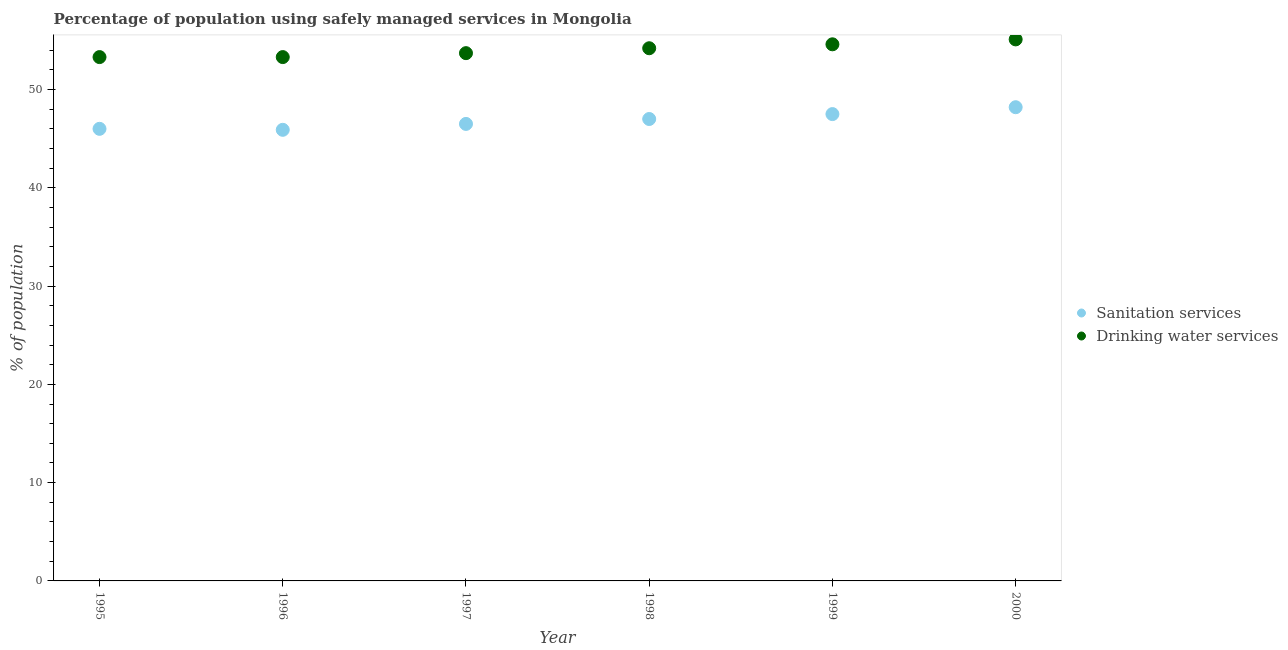Is the number of dotlines equal to the number of legend labels?
Offer a terse response. Yes. What is the percentage of population who used drinking water services in 2000?
Provide a succinct answer. 55.1. Across all years, what is the maximum percentage of population who used drinking water services?
Give a very brief answer. 55.1. Across all years, what is the minimum percentage of population who used sanitation services?
Keep it short and to the point. 45.9. In which year was the percentage of population who used drinking water services maximum?
Provide a short and direct response. 2000. What is the total percentage of population who used drinking water services in the graph?
Give a very brief answer. 324.2. What is the difference between the percentage of population who used sanitation services in 1998 and that in 1999?
Give a very brief answer. -0.5. What is the difference between the percentage of population who used sanitation services in 1997 and the percentage of population who used drinking water services in 1996?
Offer a terse response. -6.8. What is the average percentage of population who used sanitation services per year?
Offer a very short reply. 46.85. In the year 1995, what is the difference between the percentage of population who used sanitation services and percentage of population who used drinking water services?
Keep it short and to the point. -7.3. In how many years, is the percentage of population who used sanitation services greater than 30 %?
Provide a short and direct response. 6. What is the ratio of the percentage of population who used drinking water services in 1998 to that in 2000?
Offer a very short reply. 0.98. Is the percentage of population who used sanitation services in 1996 less than that in 1997?
Make the answer very short. Yes. What is the difference between the highest and the second highest percentage of population who used drinking water services?
Offer a terse response. 0.5. What is the difference between the highest and the lowest percentage of population who used drinking water services?
Ensure brevity in your answer.  1.8. Is the percentage of population who used drinking water services strictly less than the percentage of population who used sanitation services over the years?
Make the answer very short. No. How many years are there in the graph?
Keep it short and to the point. 6. Are the values on the major ticks of Y-axis written in scientific E-notation?
Your answer should be very brief. No. Does the graph contain grids?
Your answer should be very brief. No. What is the title of the graph?
Ensure brevity in your answer.  Percentage of population using safely managed services in Mongolia. Does "Goods" appear as one of the legend labels in the graph?
Make the answer very short. No. What is the label or title of the X-axis?
Offer a terse response. Year. What is the label or title of the Y-axis?
Offer a very short reply. % of population. What is the % of population in Drinking water services in 1995?
Keep it short and to the point. 53.3. What is the % of population of Sanitation services in 1996?
Offer a terse response. 45.9. What is the % of population of Drinking water services in 1996?
Provide a succinct answer. 53.3. What is the % of population of Sanitation services in 1997?
Your response must be concise. 46.5. What is the % of population in Drinking water services in 1997?
Ensure brevity in your answer.  53.7. What is the % of population in Drinking water services in 1998?
Provide a short and direct response. 54.2. What is the % of population of Sanitation services in 1999?
Your response must be concise. 47.5. What is the % of population in Drinking water services in 1999?
Provide a short and direct response. 54.6. What is the % of population of Sanitation services in 2000?
Your answer should be very brief. 48.2. What is the % of population of Drinking water services in 2000?
Provide a succinct answer. 55.1. Across all years, what is the maximum % of population in Sanitation services?
Provide a short and direct response. 48.2. Across all years, what is the maximum % of population of Drinking water services?
Offer a very short reply. 55.1. Across all years, what is the minimum % of population of Sanitation services?
Keep it short and to the point. 45.9. Across all years, what is the minimum % of population of Drinking water services?
Keep it short and to the point. 53.3. What is the total % of population of Sanitation services in the graph?
Offer a very short reply. 281.1. What is the total % of population of Drinking water services in the graph?
Ensure brevity in your answer.  324.2. What is the difference between the % of population of Sanitation services in 1995 and that in 1997?
Keep it short and to the point. -0.5. What is the difference between the % of population of Sanitation services in 1995 and that in 1999?
Ensure brevity in your answer.  -1.5. What is the difference between the % of population of Sanitation services in 1995 and that in 2000?
Provide a short and direct response. -2.2. What is the difference between the % of population of Drinking water services in 1995 and that in 2000?
Make the answer very short. -1.8. What is the difference between the % of population of Sanitation services in 1996 and that in 1997?
Make the answer very short. -0.6. What is the difference between the % of population in Sanitation services in 1996 and that in 1998?
Provide a succinct answer. -1.1. What is the difference between the % of population in Drinking water services in 1996 and that in 1998?
Give a very brief answer. -0.9. What is the difference between the % of population of Drinking water services in 1996 and that in 1999?
Ensure brevity in your answer.  -1.3. What is the difference between the % of population in Drinking water services in 1997 and that in 1999?
Keep it short and to the point. -0.9. What is the difference between the % of population in Sanitation services in 1998 and that in 1999?
Offer a very short reply. -0.5. What is the difference between the % of population in Drinking water services in 1998 and that in 1999?
Offer a terse response. -0.4. What is the difference between the % of population in Sanitation services in 1998 and that in 2000?
Keep it short and to the point. -1.2. What is the difference between the % of population in Drinking water services in 1999 and that in 2000?
Offer a very short reply. -0.5. What is the difference between the % of population of Sanitation services in 1995 and the % of population of Drinking water services in 1997?
Ensure brevity in your answer.  -7.7. What is the difference between the % of population in Sanitation services in 1995 and the % of population in Drinking water services in 2000?
Make the answer very short. -9.1. What is the difference between the % of population in Sanitation services in 1996 and the % of population in Drinking water services in 1998?
Offer a very short reply. -8.3. What is the difference between the % of population of Sanitation services in 1996 and the % of population of Drinking water services in 1999?
Ensure brevity in your answer.  -8.7. What is the difference between the % of population of Sanitation services in 1996 and the % of population of Drinking water services in 2000?
Your response must be concise. -9.2. What is the difference between the % of population of Sanitation services in 1997 and the % of population of Drinking water services in 1998?
Keep it short and to the point. -7.7. What is the difference between the % of population of Sanitation services in 1997 and the % of population of Drinking water services in 1999?
Make the answer very short. -8.1. What is the difference between the % of population in Sanitation services in 1998 and the % of population in Drinking water services in 1999?
Your answer should be very brief. -7.6. What is the difference between the % of population of Sanitation services in 1998 and the % of population of Drinking water services in 2000?
Your answer should be compact. -8.1. What is the difference between the % of population in Sanitation services in 1999 and the % of population in Drinking water services in 2000?
Ensure brevity in your answer.  -7.6. What is the average % of population of Sanitation services per year?
Keep it short and to the point. 46.85. What is the average % of population of Drinking water services per year?
Your answer should be compact. 54.03. In the year 1995, what is the difference between the % of population in Sanitation services and % of population in Drinking water services?
Your answer should be compact. -7.3. In the year 1998, what is the difference between the % of population in Sanitation services and % of population in Drinking water services?
Your answer should be very brief. -7.2. In the year 1999, what is the difference between the % of population in Sanitation services and % of population in Drinking water services?
Your response must be concise. -7.1. What is the ratio of the % of population of Sanitation services in 1995 to that in 1996?
Offer a terse response. 1. What is the ratio of the % of population in Drinking water services in 1995 to that in 1996?
Ensure brevity in your answer.  1. What is the ratio of the % of population of Sanitation services in 1995 to that in 1997?
Offer a terse response. 0.99. What is the ratio of the % of population of Sanitation services in 1995 to that in 1998?
Offer a terse response. 0.98. What is the ratio of the % of population of Drinking water services in 1995 to that in 1998?
Your answer should be very brief. 0.98. What is the ratio of the % of population in Sanitation services in 1995 to that in 1999?
Make the answer very short. 0.97. What is the ratio of the % of population in Drinking water services in 1995 to that in 1999?
Your response must be concise. 0.98. What is the ratio of the % of population of Sanitation services in 1995 to that in 2000?
Your response must be concise. 0.95. What is the ratio of the % of population in Drinking water services in 1995 to that in 2000?
Your answer should be very brief. 0.97. What is the ratio of the % of population of Sanitation services in 1996 to that in 1997?
Your answer should be compact. 0.99. What is the ratio of the % of population in Drinking water services in 1996 to that in 1997?
Make the answer very short. 0.99. What is the ratio of the % of population of Sanitation services in 1996 to that in 1998?
Your response must be concise. 0.98. What is the ratio of the % of population of Drinking water services in 1996 to that in 1998?
Provide a succinct answer. 0.98. What is the ratio of the % of population of Sanitation services in 1996 to that in 1999?
Offer a terse response. 0.97. What is the ratio of the % of population of Drinking water services in 1996 to that in 1999?
Your answer should be compact. 0.98. What is the ratio of the % of population of Sanitation services in 1996 to that in 2000?
Offer a terse response. 0.95. What is the ratio of the % of population of Drinking water services in 1996 to that in 2000?
Your answer should be compact. 0.97. What is the ratio of the % of population in Sanitation services in 1997 to that in 1998?
Offer a terse response. 0.99. What is the ratio of the % of population of Drinking water services in 1997 to that in 1998?
Offer a very short reply. 0.99. What is the ratio of the % of population in Sanitation services in 1997 to that in 1999?
Keep it short and to the point. 0.98. What is the ratio of the % of population of Drinking water services in 1997 to that in 1999?
Your response must be concise. 0.98. What is the ratio of the % of population of Sanitation services in 1997 to that in 2000?
Give a very brief answer. 0.96. What is the ratio of the % of population in Drinking water services in 1997 to that in 2000?
Provide a short and direct response. 0.97. What is the ratio of the % of population of Drinking water services in 1998 to that in 1999?
Make the answer very short. 0.99. What is the ratio of the % of population in Sanitation services in 1998 to that in 2000?
Your answer should be compact. 0.98. What is the ratio of the % of population of Drinking water services in 1998 to that in 2000?
Ensure brevity in your answer.  0.98. What is the ratio of the % of population of Sanitation services in 1999 to that in 2000?
Your response must be concise. 0.99. What is the ratio of the % of population in Drinking water services in 1999 to that in 2000?
Give a very brief answer. 0.99. What is the difference between the highest and the second highest % of population in Drinking water services?
Your answer should be very brief. 0.5. What is the difference between the highest and the lowest % of population of Sanitation services?
Keep it short and to the point. 2.3. 